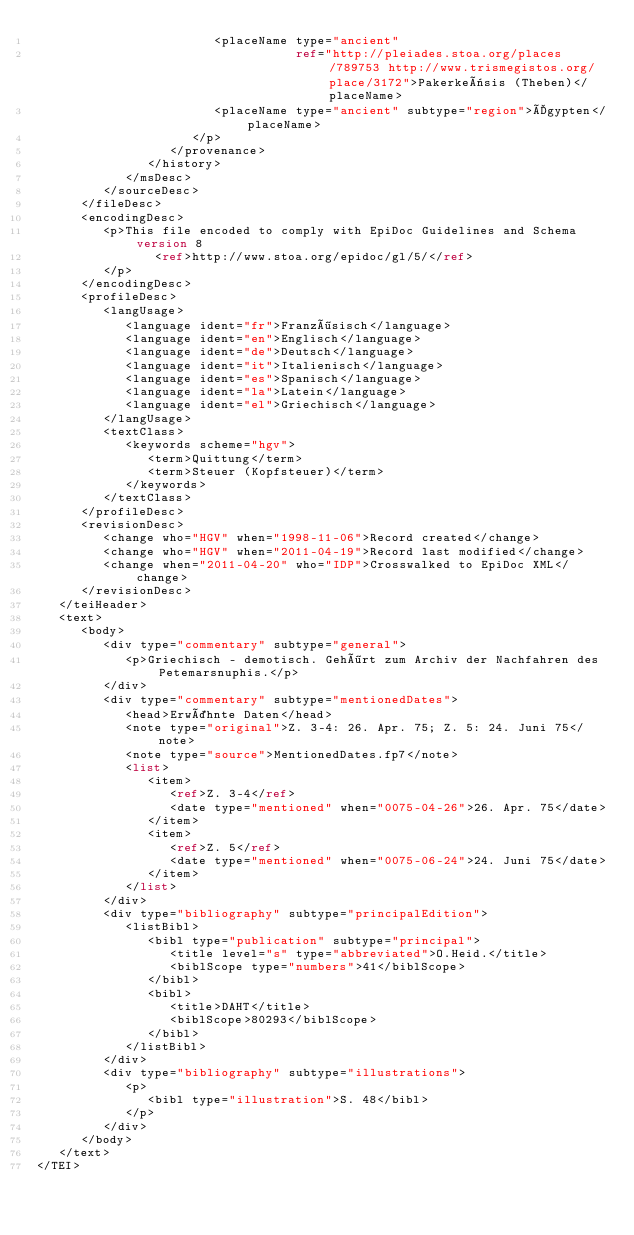<code> <loc_0><loc_0><loc_500><loc_500><_XML_>                        <placeName type="ancient"
                                   ref="http://pleiades.stoa.org/places/789753 http://www.trismegistos.org/place/3172">Pakerkeësis (Theben)</placeName>
                        <placeName type="ancient" subtype="region">Ägypten</placeName>
                     </p>
                  </provenance>
               </history>
            </msDesc>
         </sourceDesc>
      </fileDesc>
      <encodingDesc>
         <p>This file encoded to comply with EpiDoc Guidelines and Schema version 8
                <ref>http://www.stoa.org/epidoc/gl/5/</ref>
         </p>
      </encodingDesc>
      <profileDesc>
         <langUsage>
            <language ident="fr">Französisch</language>
            <language ident="en">Englisch</language>
            <language ident="de">Deutsch</language>
            <language ident="it">Italienisch</language>
            <language ident="es">Spanisch</language>
            <language ident="la">Latein</language>
            <language ident="el">Griechisch</language>
         </langUsage>
         <textClass>
            <keywords scheme="hgv">
               <term>Quittung</term>
               <term>Steuer (Kopfsteuer)</term>
            </keywords>
         </textClass>
      </profileDesc>
      <revisionDesc>
         <change who="HGV" when="1998-11-06">Record created</change>
         <change who="HGV" when="2011-04-19">Record last modified</change>
         <change when="2011-04-20" who="IDP">Crosswalked to EpiDoc XML</change>
      </revisionDesc>
   </teiHeader>
   <text>
      <body>
         <div type="commentary" subtype="general">
            <p>Griechisch - demotisch. Gehört zum Archiv der Nachfahren des Petemarsnuphis.</p>
         </div>
         <div type="commentary" subtype="mentionedDates">
            <head>Erwähnte Daten</head>
            <note type="original">Z. 3-4: 26. Apr. 75; Z. 5: 24. Juni 75</note>
            <note type="source">MentionedDates.fp7</note>
            <list>
               <item>
                  <ref>Z. 3-4</ref>
                  <date type="mentioned" when="0075-04-26">26. Apr. 75</date>
               </item>
               <item>
                  <ref>Z. 5</ref>
                  <date type="mentioned" when="0075-06-24">24. Juni 75</date>
               </item>
            </list>
         </div>
         <div type="bibliography" subtype="principalEdition">
            <listBibl>
               <bibl type="publication" subtype="principal">
                  <title level="s" type="abbreviated">O.Heid.</title>
                  <biblScope type="numbers">41</biblScope>
               </bibl>
               <bibl>
                  <title>DAHT</title>
                  <biblScope>80293</biblScope>
               </bibl>
            </listBibl>
         </div>
         <div type="bibliography" subtype="illustrations">
            <p>
               <bibl type="illustration">S. 48</bibl>
            </p>
         </div>
      </body>
   </text>
</TEI>
</code> 